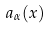Convert formula to latex. <formula><loc_0><loc_0><loc_500><loc_500>a _ { \alpha } ( x )</formula> 